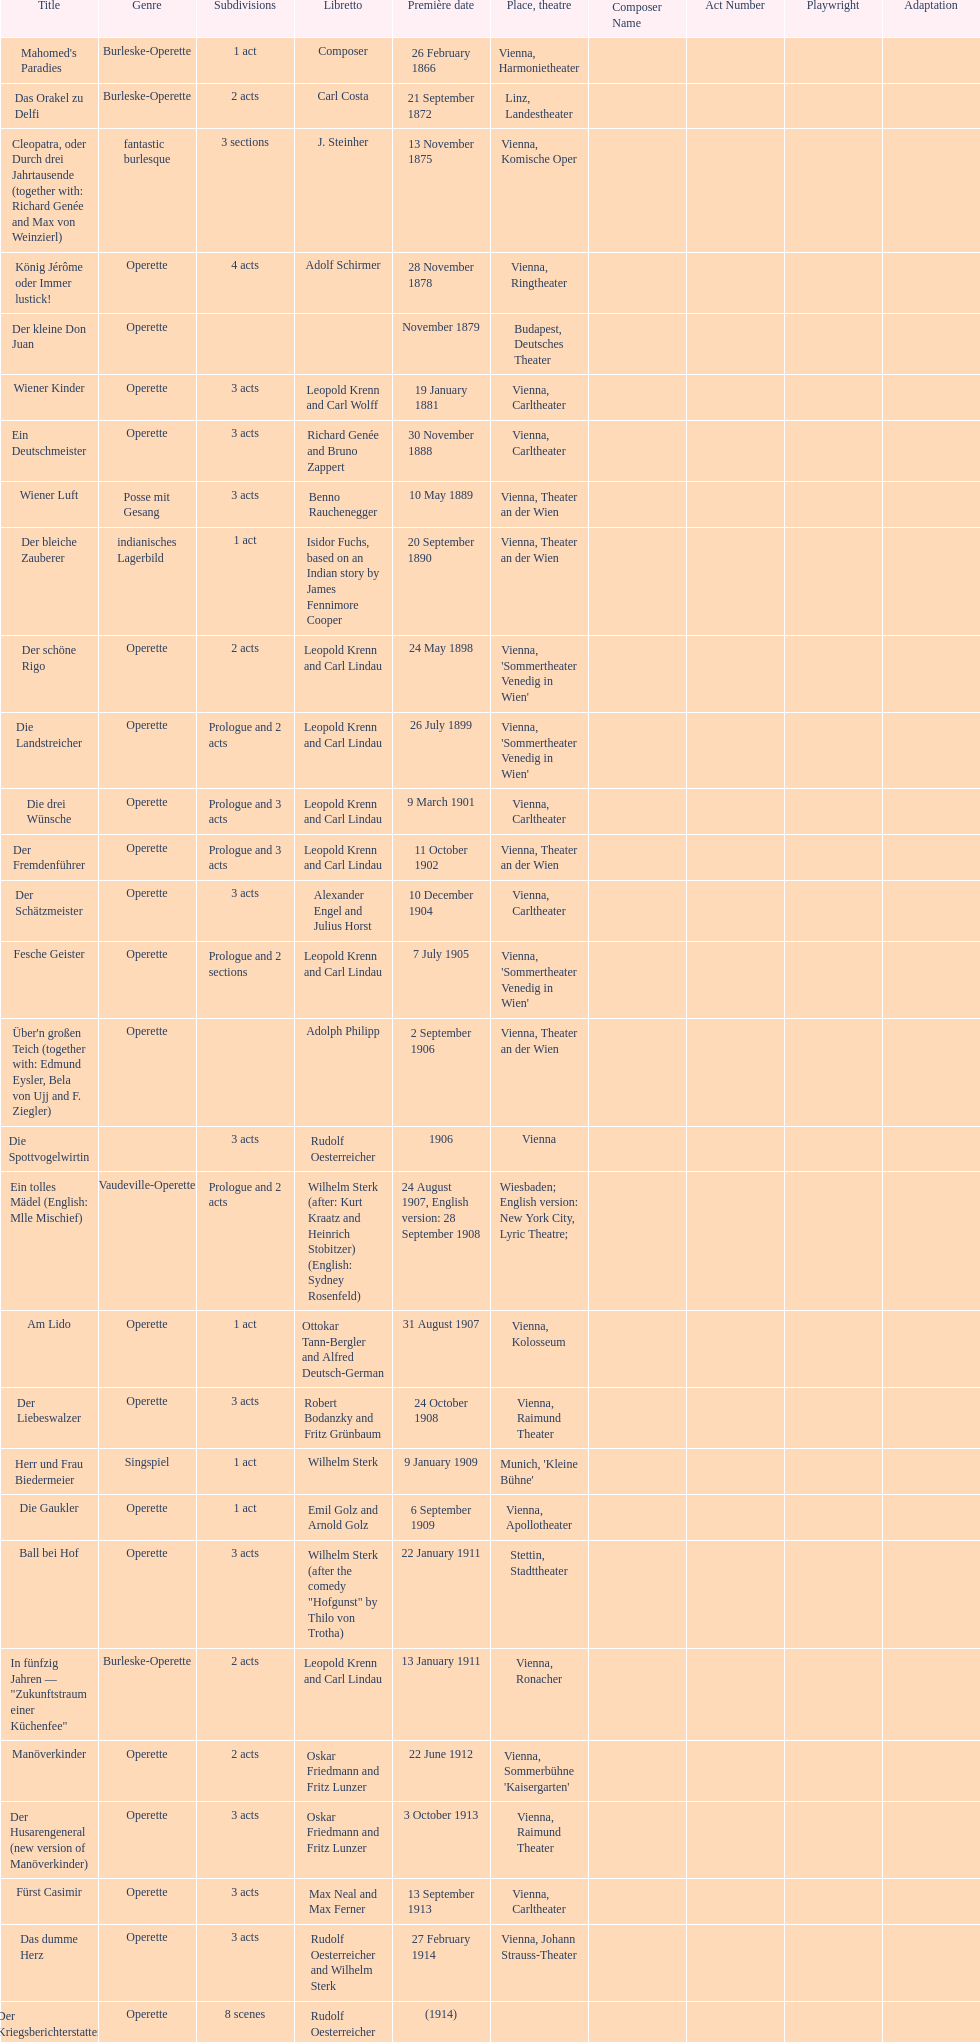All the dates are no later than what year? 1958. 